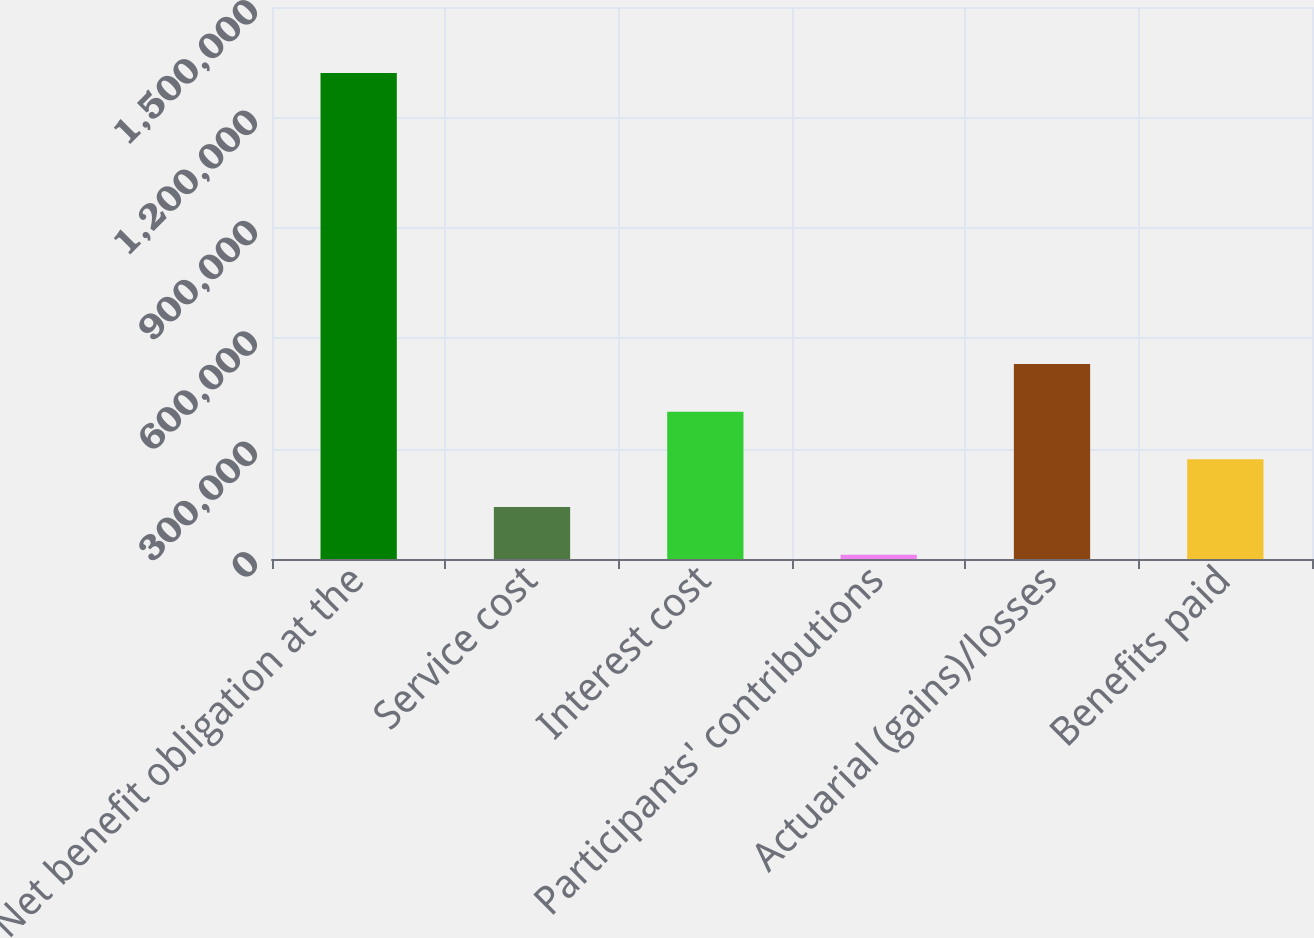Convert chart to OTSL. <chart><loc_0><loc_0><loc_500><loc_500><bar_chart><fcel>Net benefit obligation at the<fcel>Service cost<fcel>Interest cost<fcel>Participants' contributions<fcel>Actuarial (gains)/losses<fcel>Benefits paid<nl><fcel>1.3209e+06<fcel>141358<fcel>400463<fcel>11805<fcel>530015<fcel>270910<nl></chart> 